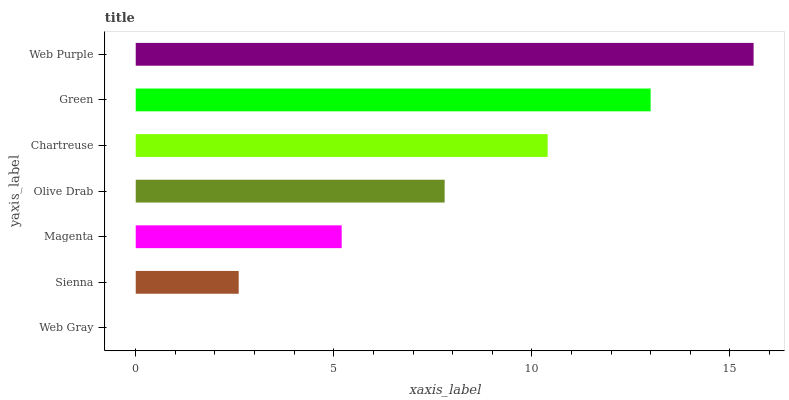Is Web Gray the minimum?
Answer yes or no. Yes. Is Web Purple the maximum?
Answer yes or no. Yes. Is Sienna the minimum?
Answer yes or no. No. Is Sienna the maximum?
Answer yes or no. No. Is Sienna greater than Web Gray?
Answer yes or no. Yes. Is Web Gray less than Sienna?
Answer yes or no. Yes. Is Web Gray greater than Sienna?
Answer yes or no. No. Is Sienna less than Web Gray?
Answer yes or no. No. Is Olive Drab the high median?
Answer yes or no. Yes. Is Olive Drab the low median?
Answer yes or no. Yes. Is Green the high median?
Answer yes or no. No. Is Green the low median?
Answer yes or no. No. 